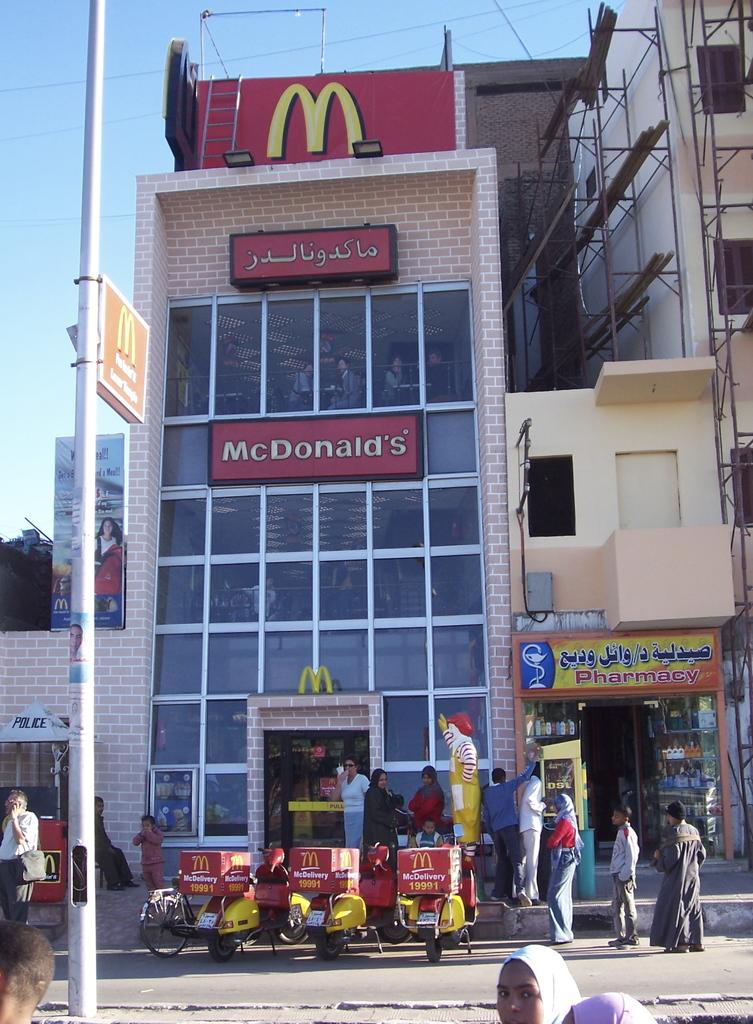What's the name of this restaurant?
Offer a terse response. Mcdonald's. Is that a pharmacy next to mcdonald's?
Offer a very short reply. Yes. 